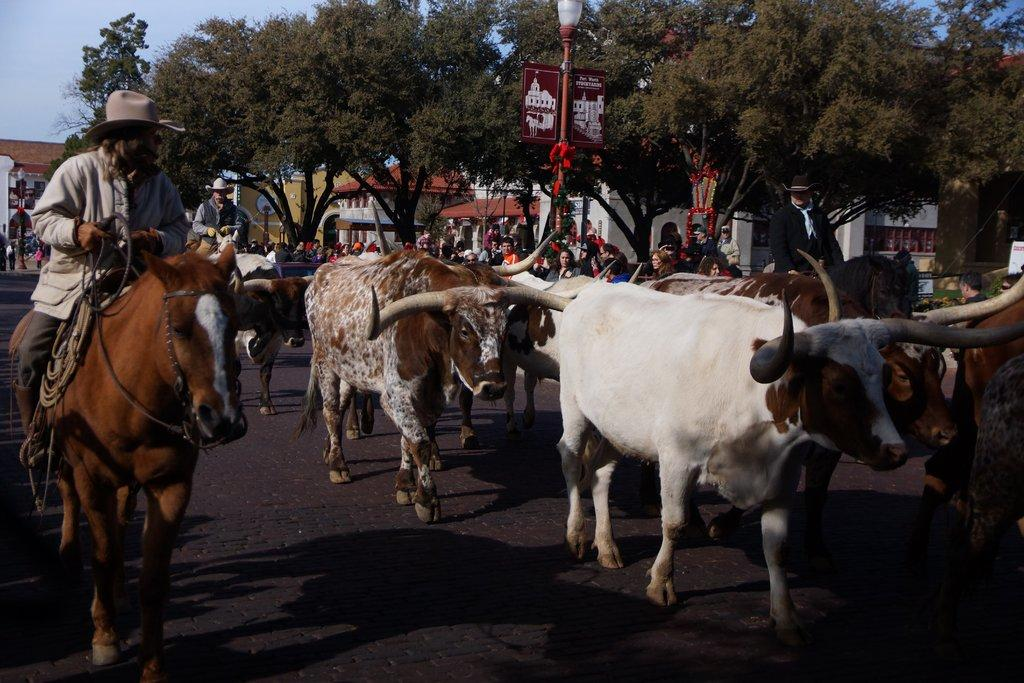What types of living organisms can be seen in the image? There are animals in the image. What are the people in the image doing with the animals? People are sitting on horses in the image. What structures can be seen in the image? There are buildings in the image. What type of vegetation is present in the image? Trees are present in the image. What signage is visible in the image? Name boards are visible in the image. How many people are in the group in the image? There is a group of people in the image. What can be seen in the background of the image? The sky is visible in the background of the image. What type of band is playing in the image? There is no band present in the image. How many women are visible in the image? The image does not specify the gender of the people in the group, so it cannot be determined how many women are present. 